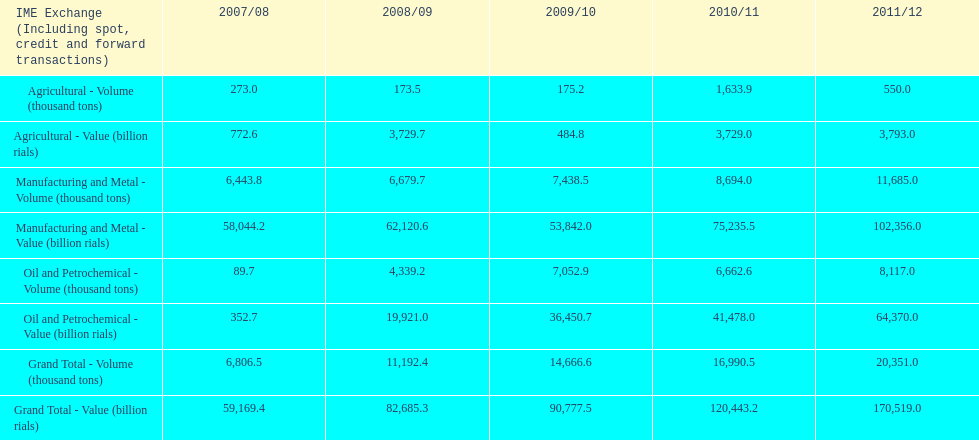How many successive years did the overall total value increase in iran? 4. 